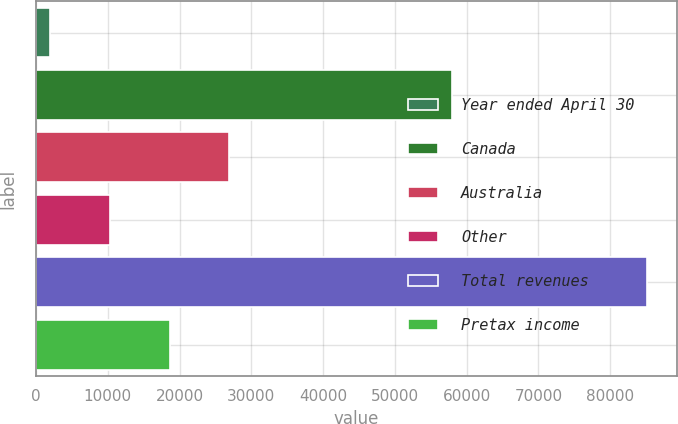Convert chart to OTSL. <chart><loc_0><loc_0><loc_500><loc_500><bar_chart><fcel>Year ended April 30<fcel>Canada<fcel>Australia<fcel>Other<fcel>Total revenues<fcel>Pretax income<nl><fcel>2003<fcel>57985<fcel>26926.7<fcel>10310.9<fcel>85082<fcel>18618.8<nl></chart> 